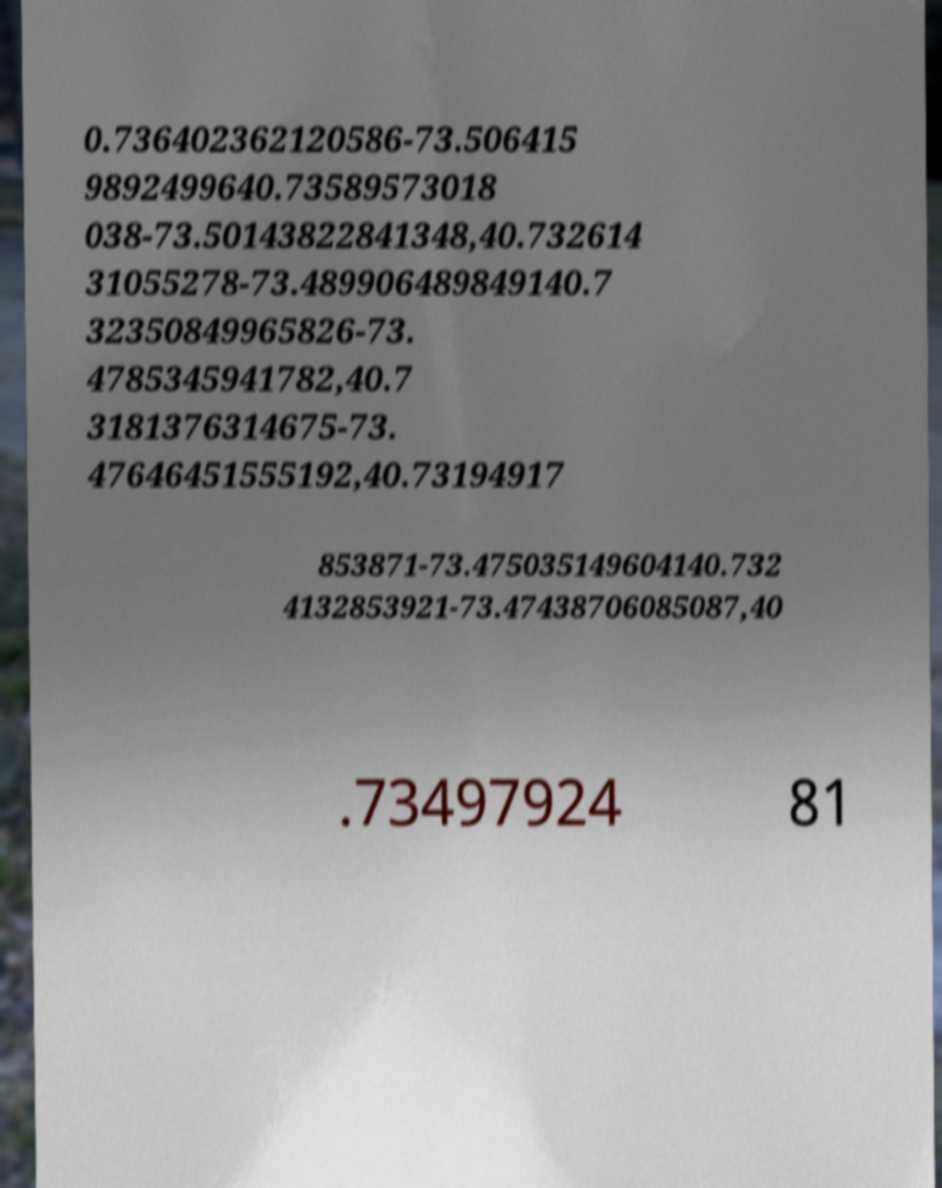Please read and relay the text visible in this image. What does it say? 0.736402362120586-73.506415 9892499640.73589573018 038-73.50143822841348,40.732614 31055278-73.489906489849140.7 32350849965826-73. 4785345941782,40.7 3181376314675-73. 47646451555192,40.73194917 853871-73.475035149604140.732 4132853921-73.47438706085087,40 .73497924 81 